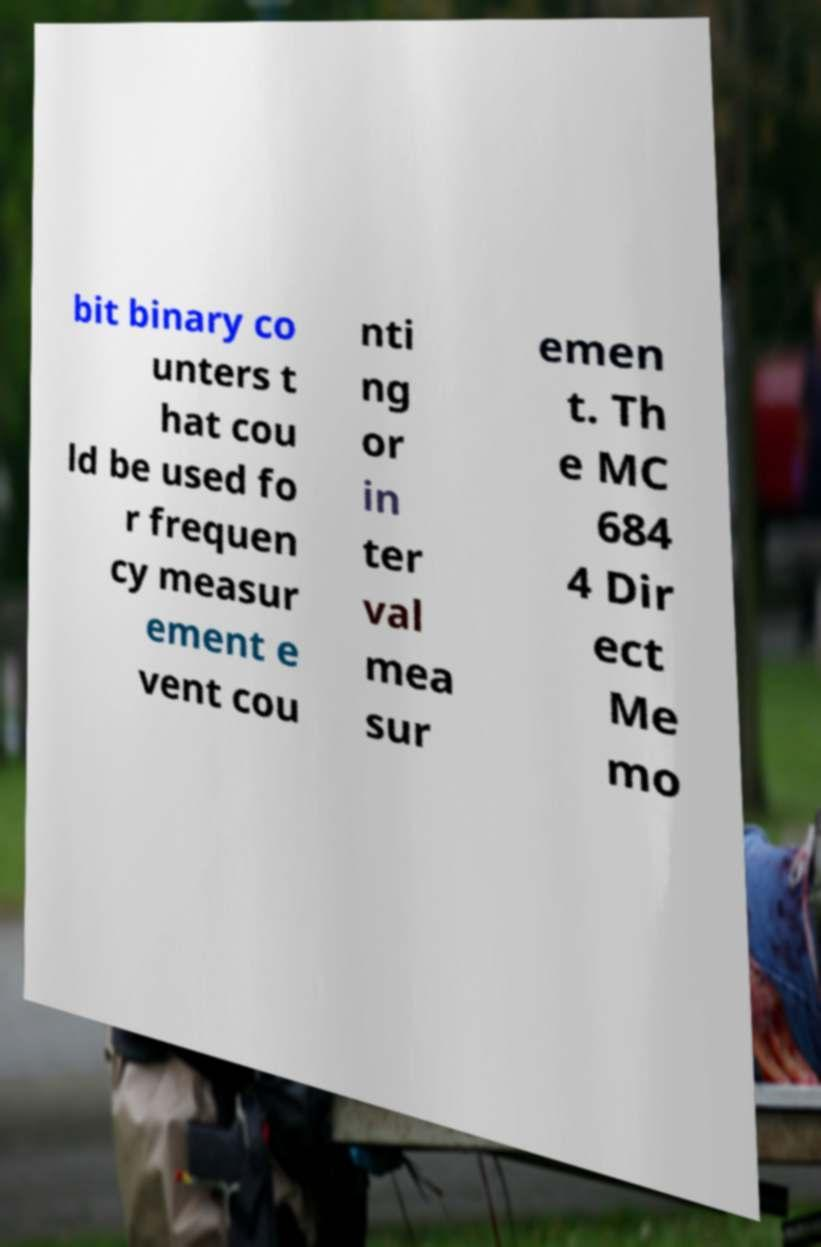There's text embedded in this image that I need extracted. Can you transcribe it verbatim? bit binary co unters t hat cou ld be used fo r frequen cy measur ement e vent cou nti ng or in ter val mea sur emen t. Th e MC 684 4 Dir ect Me mo 